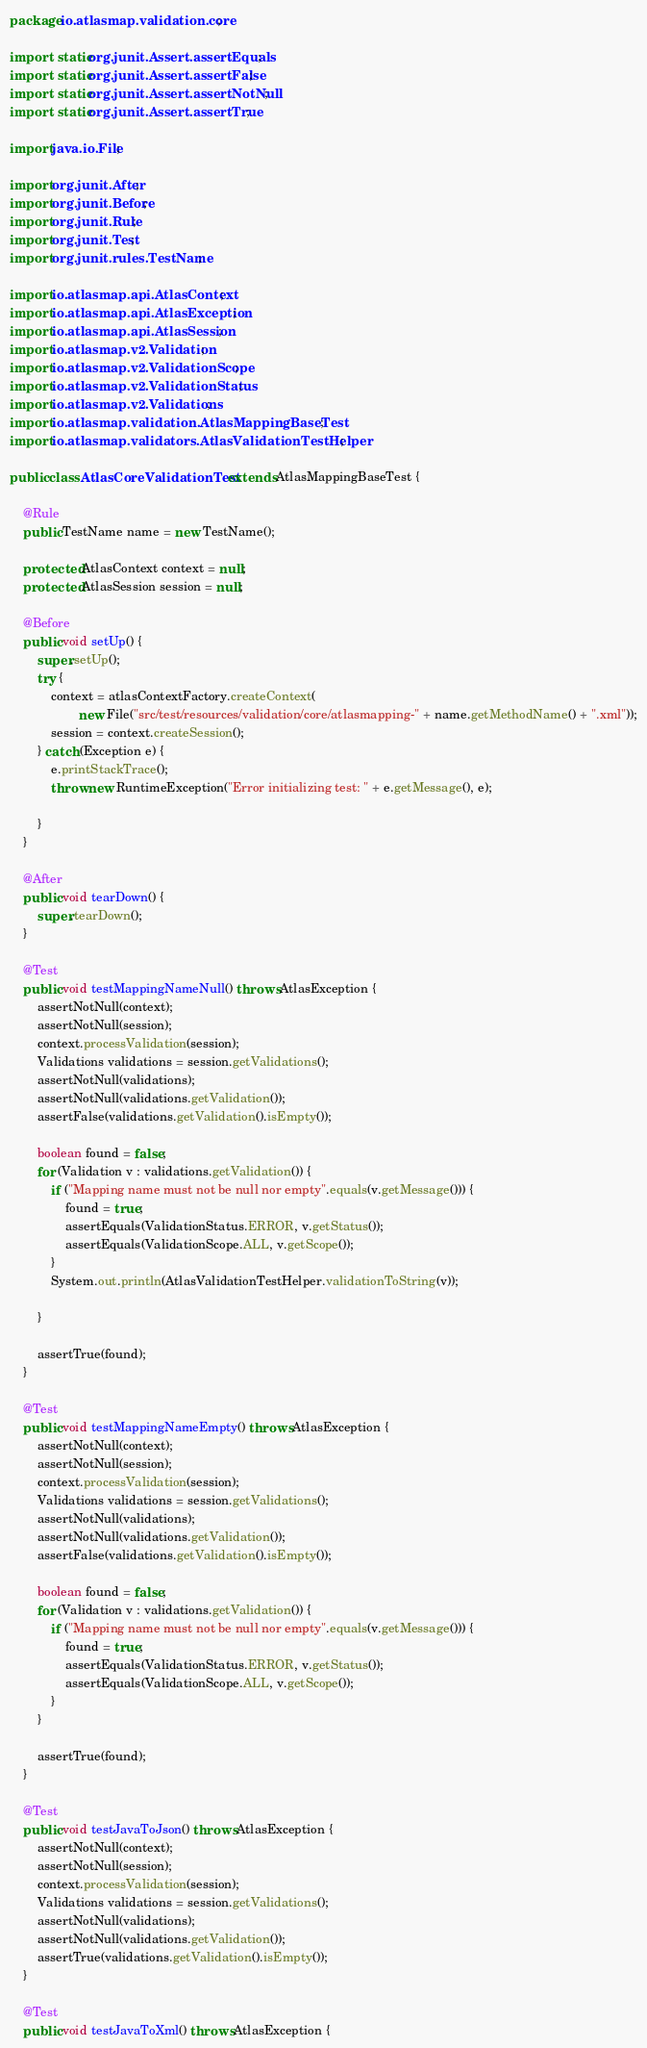<code> <loc_0><loc_0><loc_500><loc_500><_Java_>package io.atlasmap.validation.core;

import static org.junit.Assert.assertEquals;
import static org.junit.Assert.assertFalse;
import static org.junit.Assert.assertNotNull;
import static org.junit.Assert.assertTrue;

import java.io.File;

import org.junit.After;
import org.junit.Before;
import org.junit.Rule;
import org.junit.Test;
import org.junit.rules.TestName;

import io.atlasmap.api.AtlasContext;
import io.atlasmap.api.AtlasException;
import io.atlasmap.api.AtlasSession;
import io.atlasmap.v2.Validation;
import io.atlasmap.v2.ValidationScope;
import io.atlasmap.v2.ValidationStatus;
import io.atlasmap.v2.Validations;
import io.atlasmap.validation.AtlasMappingBaseTest;
import io.atlasmap.validators.AtlasValidationTestHelper;

public class AtlasCoreValidationTest extends AtlasMappingBaseTest {

    @Rule
    public TestName name = new TestName();

    protected AtlasContext context = null;
    protected AtlasSession session = null;

    @Before
    public void setUp() {
        super.setUp();
        try {
            context = atlasContextFactory.createContext(
                    new File("src/test/resources/validation/core/atlasmapping-" + name.getMethodName() + ".xml"));
            session = context.createSession();
        } catch (Exception e) {
            e.printStackTrace();
            throw new RuntimeException("Error initializing test: " + e.getMessage(), e);

        }
    }

    @After
    public void tearDown() {
        super.tearDown();
    }

    @Test
    public void testMappingNameNull() throws AtlasException {
        assertNotNull(context);
        assertNotNull(session);
        context.processValidation(session);
        Validations validations = session.getValidations();
        assertNotNull(validations);
        assertNotNull(validations.getValidation());
        assertFalse(validations.getValidation().isEmpty());

        boolean found = false;
        for (Validation v : validations.getValidation()) {
            if ("Mapping name must not be null nor empty".equals(v.getMessage())) {
                found = true;
                assertEquals(ValidationStatus.ERROR, v.getStatus());
                assertEquals(ValidationScope.ALL, v.getScope());
            }
            System.out.println(AtlasValidationTestHelper.validationToString(v));

        }

        assertTrue(found);
    }

    @Test
    public void testMappingNameEmpty() throws AtlasException {
        assertNotNull(context);
        assertNotNull(session);
        context.processValidation(session);
        Validations validations = session.getValidations();
        assertNotNull(validations);
        assertNotNull(validations.getValidation());
        assertFalse(validations.getValidation().isEmpty());

        boolean found = false;
        for (Validation v : validations.getValidation()) {
            if ("Mapping name must not be null nor empty".equals(v.getMessage())) {
                found = true;
                assertEquals(ValidationStatus.ERROR, v.getStatus());
                assertEquals(ValidationScope.ALL, v.getScope());
            }
        }

        assertTrue(found);
    }

    @Test
    public void testJavaToJson() throws AtlasException {
        assertNotNull(context);
        assertNotNull(session);
        context.processValidation(session);
        Validations validations = session.getValidations();
        assertNotNull(validations);
        assertNotNull(validations.getValidation());
        assertTrue(validations.getValidation().isEmpty());
    }

    @Test
    public void testJavaToXml() throws AtlasException {</code> 